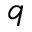Convert formula to latex. <formula><loc_0><loc_0><loc_500><loc_500>q</formula> 